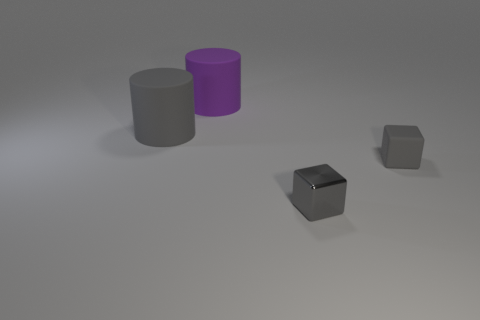There is a purple thing that is the same shape as the large gray object; what is its material?
Provide a succinct answer. Rubber. The small gray metallic object is what shape?
Make the answer very short. Cube. The gray object that is both to the left of the small gray rubber block and to the right of the big purple cylinder is made of what material?
Ensure brevity in your answer.  Metal. The tiny thing that is the same material as the large purple object is what shape?
Make the answer very short. Cube. What is the size of the gray block that is the same material as the large gray thing?
Provide a succinct answer. Small. What is the shape of the rubber object that is both on the left side of the metal thing and in front of the purple object?
Provide a succinct answer. Cylinder. There is a object that is on the right side of the gray metallic thing that is left of the gray matte block; how big is it?
Your response must be concise. Small. What number of other things are the same color as the metallic thing?
Give a very brief answer. 2. What is the gray cylinder made of?
Provide a succinct answer. Rubber. Is there a gray cylinder?
Provide a succinct answer. Yes. 